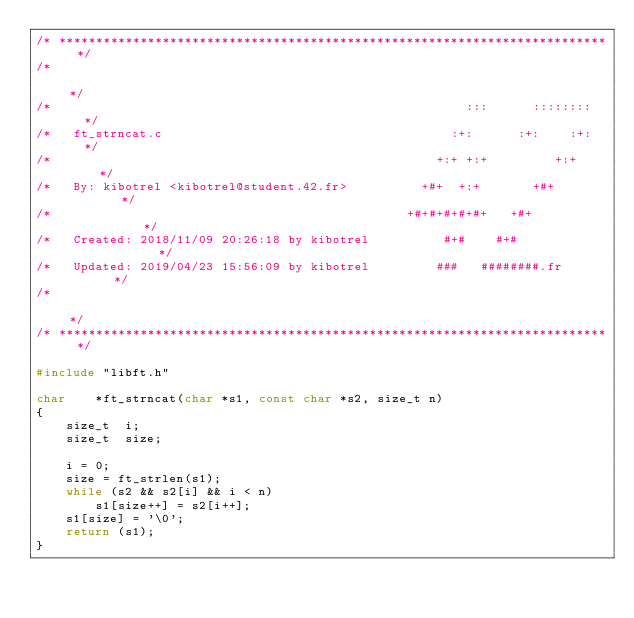<code> <loc_0><loc_0><loc_500><loc_500><_C_>/* ************************************************************************** */
/*                                                                            */
/*                                                        :::      ::::::::   */
/*   ft_strncat.c                                       :+:      :+:    :+:   */
/*                                                    +:+ +:+         +:+     */
/*   By: kibotrel <kibotrel@student.42.fr>          +#+  +:+       +#+        */
/*                                                +#+#+#+#+#+   +#+           */
/*   Created: 2018/11/09 20:26:18 by kibotrel          #+#    #+#             */
/*   Updated: 2019/04/23 15:56:09 by kibotrel         ###   ########.fr       */
/*                                                                            */
/* ************************************************************************** */

#include "libft.h"

char	*ft_strncat(char *s1, const char *s2, size_t n)
{
	size_t	i;
	size_t	size;

	i = 0;
	size = ft_strlen(s1);
	while (s2 && s2[i] && i < n)
		s1[size++] = s2[i++];
	s1[size] = '\0';
	return (s1);
}
</code> 